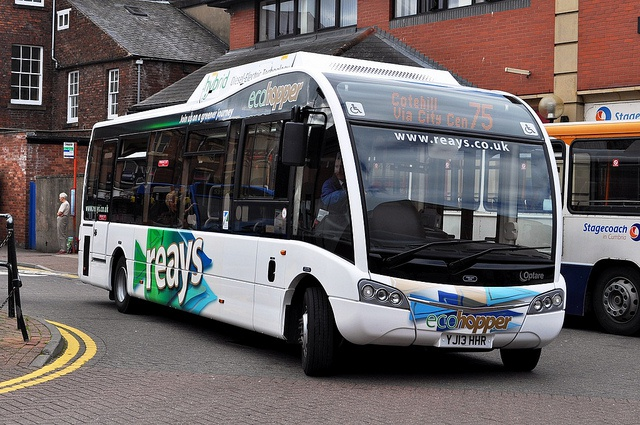Describe the objects in this image and their specific colors. I can see bus in black, lightgray, gray, and darkgray tones, bus in black, darkgray, gray, and lightgray tones, people in black, navy, gray, and darkblue tones, people in black, gray, darkgray, and lightgray tones, and people in black, maroon, and gray tones in this image. 